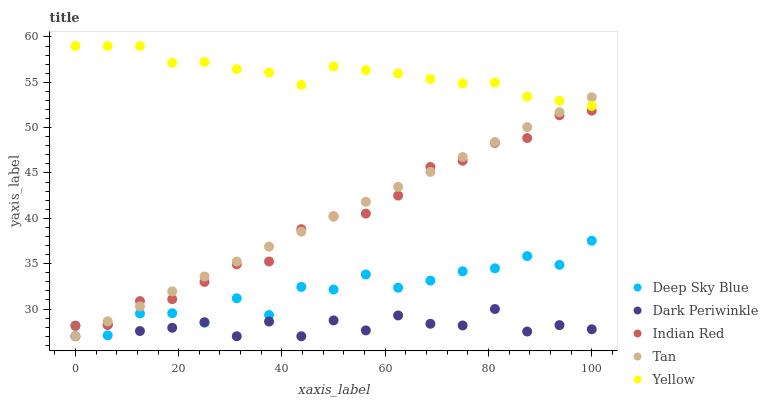Does Dark Periwinkle have the minimum area under the curve?
Answer yes or no. Yes. Does Yellow have the maximum area under the curve?
Answer yes or no. Yes. Does Tan have the minimum area under the curve?
Answer yes or no. No. Does Tan have the maximum area under the curve?
Answer yes or no. No. Is Tan the smoothest?
Answer yes or no. Yes. Is Deep Sky Blue the roughest?
Answer yes or no. Yes. Is Yellow the smoothest?
Answer yes or no. No. Is Yellow the roughest?
Answer yes or no. No. Does Tan have the lowest value?
Answer yes or no. Yes. Does Yellow have the lowest value?
Answer yes or no. No. Does Yellow have the highest value?
Answer yes or no. Yes. Does Tan have the highest value?
Answer yes or no. No. Is Deep Sky Blue less than Yellow?
Answer yes or no. Yes. Is Yellow greater than Deep Sky Blue?
Answer yes or no. Yes. Does Indian Red intersect Dark Periwinkle?
Answer yes or no. Yes. Is Indian Red less than Dark Periwinkle?
Answer yes or no. No. Is Indian Red greater than Dark Periwinkle?
Answer yes or no. No. Does Deep Sky Blue intersect Yellow?
Answer yes or no. No. 